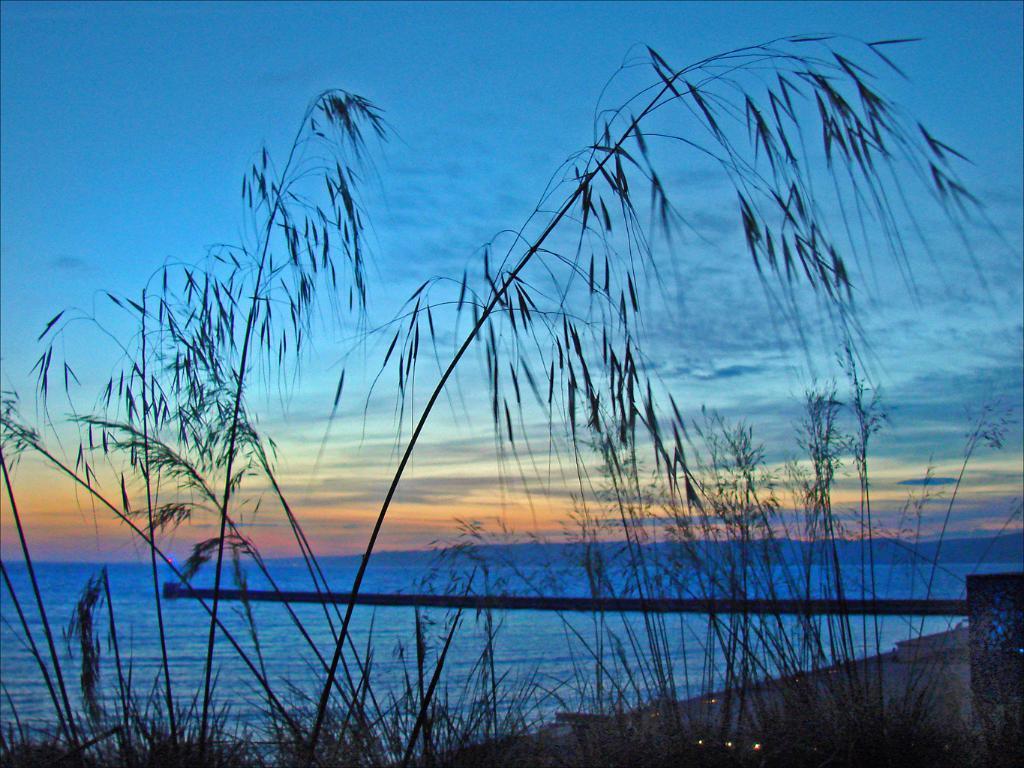In one or two sentences, can you explain what this image depicts? In this picture I can see the grass in front and I can see few lights. In the background I can see the water and I can see the sky which is a bit cloudy. 